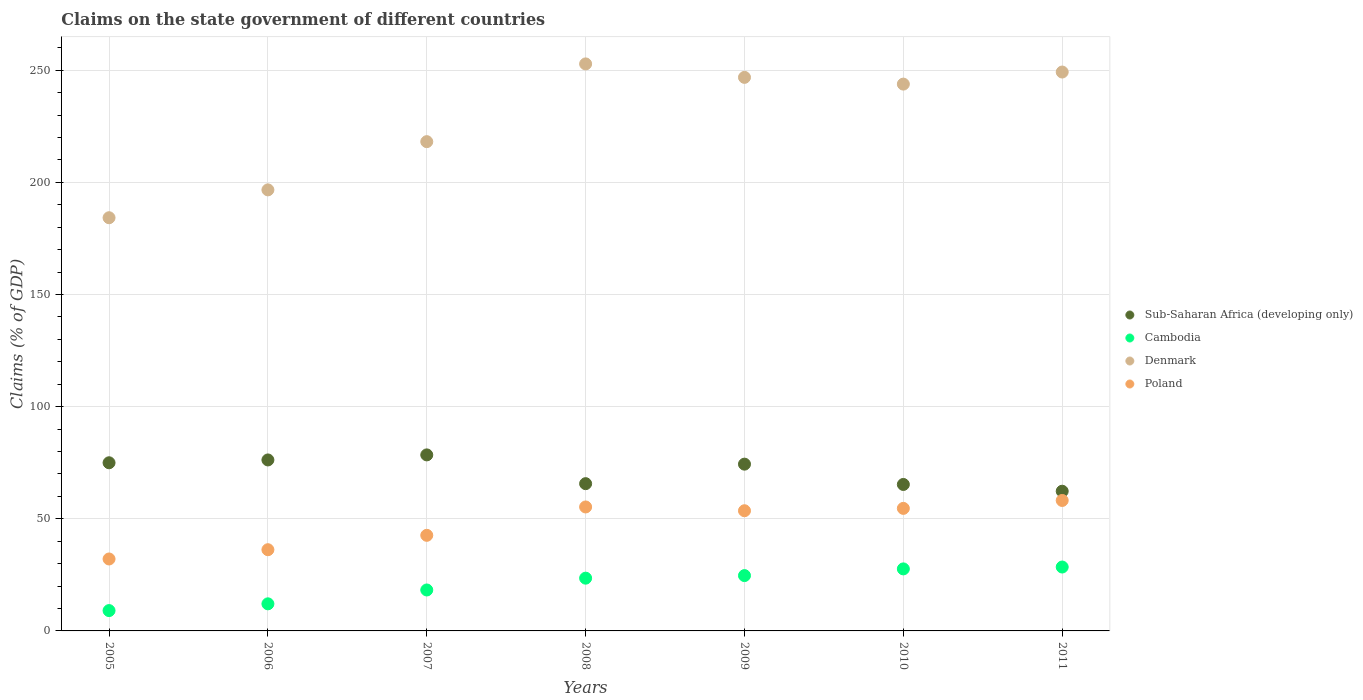Is the number of dotlines equal to the number of legend labels?
Offer a very short reply. Yes. What is the percentage of GDP claimed on the state government in Poland in 2011?
Ensure brevity in your answer.  58.16. Across all years, what is the maximum percentage of GDP claimed on the state government in Cambodia?
Keep it short and to the point. 28.49. Across all years, what is the minimum percentage of GDP claimed on the state government in Poland?
Your response must be concise. 32.08. What is the total percentage of GDP claimed on the state government in Poland in the graph?
Give a very brief answer. 332.55. What is the difference between the percentage of GDP claimed on the state government in Poland in 2005 and that in 2011?
Provide a succinct answer. -26.09. What is the difference between the percentage of GDP claimed on the state government in Cambodia in 2011 and the percentage of GDP claimed on the state government in Denmark in 2008?
Make the answer very short. -224.31. What is the average percentage of GDP claimed on the state government in Cambodia per year?
Provide a short and direct response. 20.53. In the year 2008, what is the difference between the percentage of GDP claimed on the state government in Cambodia and percentage of GDP claimed on the state government in Sub-Saharan Africa (developing only)?
Your answer should be very brief. -42.13. What is the ratio of the percentage of GDP claimed on the state government in Sub-Saharan Africa (developing only) in 2005 to that in 2007?
Offer a very short reply. 0.96. Is the difference between the percentage of GDP claimed on the state government in Cambodia in 2005 and 2008 greater than the difference between the percentage of GDP claimed on the state government in Sub-Saharan Africa (developing only) in 2005 and 2008?
Your response must be concise. No. What is the difference between the highest and the second highest percentage of GDP claimed on the state government in Sub-Saharan Africa (developing only)?
Your answer should be compact. 2.25. What is the difference between the highest and the lowest percentage of GDP claimed on the state government in Sub-Saharan Africa (developing only)?
Offer a very short reply. 16.2. Is it the case that in every year, the sum of the percentage of GDP claimed on the state government in Sub-Saharan Africa (developing only) and percentage of GDP claimed on the state government in Poland  is greater than the percentage of GDP claimed on the state government in Cambodia?
Offer a terse response. Yes. How many dotlines are there?
Your response must be concise. 4. What is the difference between two consecutive major ticks on the Y-axis?
Provide a short and direct response. 50. Does the graph contain any zero values?
Give a very brief answer. No. How many legend labels are there?
Your answer should be very brief. 4. How are the legend labels stacked?
Keep it short and to the point. Vertical. What is the title of the graph?
Your answer should be very brief. Claims on the state government of different countries. Does "Paraguay" appear as one of the legend labels in the graph?
Keep it short and to the point. No. What is the label or title of the Y-axis?
Ensure brevity in your answer.  Claims (% of GDP). What is the Claims (% of GDP) of Sub-Saharan Africa (developing only) in 2005?
Keep it short and to the point. 74.97. What is the Claims (% of GDP) in Cambodia in 2005?
Keep it short and to the point. 9.06. What is the Claims (% of GDP) of Denmark in 2005?
Ensure brevity in your answer.  184.22. What is the Claims (% of GDP) of Poland in 2005?
Your answer should be very brief. 32.08. What is the Claims (% of GDP) in Sub-Saharan Africa (developing only) in 2006?
Give a very brief answer. 76.23. What is the Claims (% of GDP) in Cambodia in 2006?
Provide a succinct answer. 12.08. What is the Claims (% of GDP) of Denmark in 2006?
Provide a short and direct response. 196.64. What is the Claims (% of GDP) of Poland in 2006?
Offer a terse response. 36.21. What is the Claims (% of GDP) in Sub-Saharan Africa (developing only) in 2007?
Your answer should be very brief. 78.48. What is the Claims (% of GDP) in Cambodia in 2007?
Offer a very short reply. 18.25. What is the Claims (% of GDP) of Denmark in 2007?
Provide a succinct answer. 218.14. What is the Claims (% of GDP) of Poland in 2007?
Provide a succinct answer. 42.62. What is the Claims (% of GDP) in Sub-Saharan Africa (developing only) in 2008?
Ensure brevity in your answer.  65.65. What is the Claims (% of GDP) in Cambodia in 2008?
Give a very brief answer. 23.52. What is the Claims (% of GDP) in Denmark in 2008?
Offer a very short reply. 252.8. What is the Claims (% of GDP) of Poland in 2008?
Offer a very short reply. 55.27. What is the Claims (% of GDP) of Sub-Saharan Africa (developing only) in 2009?
Provide a short and direct response. 74.35. What is the Claims (% of GDP) in Cambodia in 2009?
Provide a short and direct response. 24.67. What is the Claims (% of GDP) of Denmark in 2009?
Provide a succinct answer. 246.8. What is the Claims (% of GDP) of Poland in 2009?
Give a very brief answer. 53.58. What is the Claims (% of GDP) in Sub-Saharan Africa (developing only) in 2010?
Ensure brevity in your answer.  65.3. What is the Claims (% of GDP) in Cambodia in 2010?
Your answer should be compact. 27.65. What is the Claims (% of GDP) of Denmark in 2010?
Your response must be concise. 243.79. What is the Claims (% of GDP) in Poland in 2010?
Ensure brevity in your answer.  54.64. What is the Claims (% of GDP) in Sub-Saharan Africa (developing only) in 2011?
Ensure brevity in your answer.  62.28. What is the Claims (% of GDP) in Cambodia in 2011?
Give a very brief answer. 28.49. What is the Claims (% of GDP) of Denmark in 2011?
Make the answer very short. 249.18. What is the Claims (% of GDP) of Poland in 2011?
Offer a terse response. 58.16. Across all years, what is the maximum Claims (% of GDP) in Sub-Saharan Africa (developing only)?
Provide a succinct answer. 78.48. Across all years, what is the maximum Claims (% of GDP) of Cambodia?
Your response must be concise. 28.49. Across all years, what is the maximum Claims (% of GDP) of Denmark?
Offer a terse response. 252.8. Across all years, what is the maximum Claims (% of GDP) in Poland?
Offer a terse response. 58.16. Across all years, what is the minimum Claims (% of GDP) of Sub-Saharan Africa (developing only)?
Your answer should be very brief. 62.28. Across all years, what is the minimum Claims (% of GDP) in Cambodia?
Your response must be concise. 9.06. Across all years, what is the minimum Claims (% of GDP) of Denmark?
Provide a succinct answer. 184.22. Across all years, what is the minimum Claims (% of GDP) in Poland?
Provide a succinct answer. 32.08. What is the total Claims (% of GDP) in Sub-Saharan Africa (developing only) in the graph?
Your answer should be very brief. 497.27. What is the total Claims (% of GDP) of Cambodia in the graph?
Give a very brief answer. 143.72. What is the total Claims (% of GDP) of Denmark in the graph?
Your answer should be very brief. 1591.57. What is the total Claims (% of GDP) in Poland in the graph?
Make the answer very short. 332.55. What is the difference between the Claims (% of GDP) of Sub-Saharan Africa (developing only) in 2005 and that in 2006?
Your answer should be compact. -1.26. What is the difference between the Claims (% of GDP) of Cambodia in 2005 and that in 2006?
Provide a succinct answer. -3.01. What is the difference between the Claims (% of GDP) of Denmark in 2005 and that in 2006?
Offer a terse response. -12.42. What is the difference between the Claims (% of GDP) of Poland in 2005 and that in 2006?
Your response must be concise. -4.13. What is the difference between the Claims (% of GDP) in Sub-Saharan Africa (developing only) in 2005 and that in 2007?
Offer a very short reply. -3.51. What is the difference between the Claims (% of GDP) in Cambodia in 2005 and that in 2007?
Give a very brief answer. -9.19. What is the difference between the Claims (% of GDP) in Denmark in 2005 and that in 2007?
Offer a very short reply. -33.92. What is the difference between the Claims (% of GDP) in Poland in 2005 and that in 2007?
Make the answer very short. -10.54. What is the difference between the Claims (% of GDP) in Sub-Saharan Africa (developing only) in 2005 and that in 2008?
Provide a short and direct response. 9.32. What is the difference between the Claims (% of GDP) in Cambodia in 2005 and that in 2008?
Give a very brief answer. -14.46. What is the difference between the Claims (% of GDP) of Denmark in 2005 and that in 2008?
Ensure brevity in your answer.  -68.58. What is the difference between the Claims (% of GDP) in Poland in 2005 and that in 2008?
Your answer should be compact. -23.19. What is the difference between the Claims (% of GDP) in Sub-Saharan Africa (developing only) in 2005 and that in 2009?
Make the answer very short. 0.62. What is the difference between the Claims (% of GDP) of Cambodia in 2005 and that in 2009?
Your answer should be compact. -15.6. What is the difference between the Claims (% of GDP) in Denmark in 2005 and that in 2009?
Ensure brevity in your answer.  -62.58. What is the difference between the Claims (% of GDP) of Poland in 2005 and that in 2009?
Give a very brief answer. -21.51. What is the difference between the Claims (% of GDP) of Sub-Saharan Africa (developing only) in 2005 and that in 2010?
Your answer should be compact. 9.67. What is the difference between the Claims (% of GDP) in Cambodia in 2005 and that in 2010?
Your response must be concise. -18.59. What is the difference between the Claims (% of GDP) of Denmark in 2005 and that in 2010?
Your answer should be compact. -59.58. What is the difference between the Claims (% of GDP) in Poland in 2005 and that in 2010?
Make the answer very short. -22.56. What is the difference between the Claims (% of GDP) in Sub-Saharan Africa (developing only) in 2005 and that in 2011?
Make the answer very short. 12.69. What is the difference between the Claims (% of GDP) of Cambodia in 2005 and that in 2011?
Give a very brief answer. -19.42. What is the difference between the Claims (% of GDP) of Denmark in 2005 and that in 2011?
Your response must be concise. -64.96. What is the difference between the Claims (% of GDP) of Poland in 2005 and that in 2011?
Your response must be concise. -26.09. What is the difference between the Claims (% of GDP) in Sub-Saharan Africa (developing only) in 2006 and that in 2007?
Your answer should be very brief. -2.25. What is the difference between the Claims (% of GDP) of Cambodia in 2006 and that in 2007?
Your answer should be compact. -6.18. What is the difference between the Claims (% of GDP) in Denmark in 2006 and that in 2007?
Keep it short and to the point. -21.5. What is the difference between the Claims (% of GDP) in Poland in 2006 and that in 2007?
Keep it short and to the point. -6.41. What is the difference between the Claims (% of GDP) in Sub-Saharan Africa (developing only) in 2006 and that in 2008?
Keep it short and to the point. 10.58. What is the difference between the Claims (% of GDP) in Cambodia in 2006 and that in 2008?
Give a very brief answer. -11.45. What is the difference between the Claims (% of GDP) in Denmark in 2006 and that in 2008?
Make the answer very short. -56.16. What is the difference between the Claims (% of GDP) of Poland in 2006 and that in 2008?
Ensure brevity in your answer.  -19.06. What is the difference between the Claims (% of GDP) of Sub-Saharan Africa (developing only) in 2006 and that in 2009?
Offer a very short reply. 1.88. What is the difference between the Claims (% of GDP) in Cambodia in 2006 and that in 2009?
Keep it short and to the point. -12.59. What is the difference between the Claims (% of GDP) of Denmark in 2006 and that in 2009?
Keep it short and to the point. -50.16. What is the difference between the Claims (% of GDP) in Poland in 2006 and that in 2009?
Give a very brief answer. -17.37. What is the difference between the Claims (% of GDP) in Sub-Saharan Africa (developing only) in 2006 and that in 2010?
Ensure brevity in your answer.  10.93. What is the difference between the Claims (% of GDP) of Cambodia in 2006 and that in 2010?
Offer a terse response. -15.58. What is the difference between the Claims (% of GDP) of Denmark in 2006 and that in 2010?
Give a very brief answer. -47.15. What is the difference between the Claims (% of GDP) in Poland in 2006 and that in 2010?
Make the answer very short. -18.43. What is the difference between the Claims (% of GDP) in Sub-Saharan Africa (developing only) in 2006 and that in 2011?
Provide a short and direct response. 13.95. What is the difference between the Claims (% of GDP) of Cambodia in 2006 and that in 2011?
Offer a very short reply. -16.41. What is the difference between the Claims (% of GDP) in Denmark in 2006 and that in 2011?
Your response must be concise. -52.54. What is the difference between the Claims (% of GDP) of Poland in 2006 and that in 2011?
Your response must be concise. -21.96. What is the difference between the Claims (% of GDP) of Sub-Saharan Africa (developing only) in 2007 and that in 2008?
Your answer should be very brief. 12.83. What is the difference between the Claims (% of GDP) of Cambodia in 2007 and that in 2008?
Provide a short and direct response. -5.27. What is the difference between the Claims (% of GDP) of Denmark in 2007 and that in 2008?
Your answer should be compact. -34.66. What is the difference between the Claims (% of GDP) of Poland in 2007 and that in 2008?
Your answer should be very brief. -12.65. What is the difference between the Claims (% of GDP) of Sub-Saharan Africa (developing only) in 2007 and that in 2009?
Give a very brief answer. 4.13. What is the difference between the Claims (% of GDP) of Cambodia in 2007 and that in 2009?
Offer a very short reply. -6.42. What is the difference between the Claims (% of GDP) of Denmark in 2007 and that in 2009?
Provide a succinct answer. -28.66. What is the difference between the Claims (% of GDP) in Poland in 2007 and that in 2009?
Your answer should be very brief. -10.96. What is the difference between the Claims (% of GDP) of Sub-Saharan Africa (developing only) in 2007 and that in 2010?
Your answer should be compact. 13.18. What is the difference between the Claims (% of GDP) in Cambodia in 2007 and that in 2010?
Make the answer very short. -9.4. What is the difference between the Claims (% of GDP) in Denmark in 2007 and that in 2010?
Provide a succinct answer. -25.66. What is the difference between the Claims (% of GDP) of Poland in 2007 and that in 2010?
Ensure brevity in your answer.  -12.01. What is the difference between the Claims (% of GDP) of Sub-Saharan Africa (developing only) in 2007 and that in 2011?
Offer a very short reply. 16.2. What is the difference between the Claims (% of GDP) in Cambodia in 2007 and that in 2011?
Your answer should be very brief. -10.23. What is the difference between the Claims (% of GDP) of Denmark in 2007 and that in 2011?
Provide a short and direct response. -31.04. What is the difference between the Claims (% of GDP) in Poland in 2007 and that in 2011?
Provide a succinct answer. -15.54. What is the difference between the Claims (% of GDP) in Sub-Saharan Africa (developing only) in 2008 and that in 2009?
Your answer should be very brief. -8.7. What is the difference between the Claims (% of GDP) of Cambodia in 2008 and that in 2009?
Keep it short and to the point. -1.15. What is the difference between the Claims (% of GDP) of Denmark in 2008 and that in 2009?
Offer a very short reply. 6. What is the difference between the Claims (% of GDP) of Poland in 2008 and that in 2009?
Your answer should be compact. 1.68. What is the difference between the Claims (% of GDP) of Sub-Saharan Africa (developing only) in 2008 and that in 2010?
Provide a short and direct response. 0.35. What is the difference between the Claims (% of GDP) of Cambodia in 2008 and that in 2010?
Keep it short and to the point. -4.13. What is the difference between the Claims (% of GDP) in Denmark in 2008 and that in 2010?
Keep it short and to the point. 9.01. What is the difference between the Claims (% of GDP) in Poland in 2008 and that in 2010?
Provide a succinct answer. 0.63. What is the difference between the Claims (% of GDP) of Sub-Saharan Africa (developing only) in 2008 and that in 2011?
Your answer should be compact. 3.37. What is the difference between the Claims (% of GDP) in Cambodia in 2008 and that in 2011?
Your response must be concise. -4.97. What is the difference between the Claims (% of GDP) in Denmark in 2008 and that in 2011?
Offer a very short reply. 3.62. What is the difference between the Claims (% of GDP) in Poland in 2008 and that in 2011?
Your answer should be compact. -2.9. What is the difference between the Claims (% of GDP) of Sub-Saharan Africa (developing only) in 2009 and that in 2010?
Provide a short and direct response. 9.06. What is the difference between the Claims (% of GDP) in Cambodia in 2009 and that in 2010?
Your answer should be compact. -2.98. What is the difference between the Claims (% of GDP) in Denmark in 2009 and that in 2010?
Provide a succinct answer. 3. What is the difference between the Claims (% of GDP) in Poland in 2009 and that in 2010?
Offer a very short reply. -1.05. What is the difference between the Claims (% of GDP) in Sub-Saharan Africa (developing only) in 2009 and that in 2011?
Give a very brief answer. 12.07. What is the difference between the Claims (% of GDP) in Cambodia in 2009 and that in 2011?
Offer a very short reply. -3.82. What is the difference between the Claims (% of GDP) in Denmark in 2009 and that in 2011?
Provide a short and direct response. -2.38. What is the difference between the Claims (% of GDP) in Poland in 2009 and that in 2011?
Ensure brevity in your answer.  -4.58. What is the difference between the Claims (% of GDP) in Sub-Saharan Africa (developing only) in 2010 and that in 2011?
Offer a very short reply. 3.01. What is the difference between the Claims (% of GDP) of Cambodia in 2010 and that in 2011?
Offer a very short reply. -0.83. What is the difference between the Claims (% of GDP) of Denmark in 2010 and that in 2011?
Your answer should be compact. -5.38. What is the difference between the Claims (% of GDP) of Poland in 2010 and that in 2011?
Ensure brevity in your answer.  -3.53. What is the difference between the Claims (% of GDP) of Sub-Saharan Africa (developing only) in 2005 and the Claims (% of GDP) of Cambodia in 2006?
Offer a very short reply. 62.89. What is the difference between the Claims (% of GDP) of Sub-Saharan Africa (developing only) in 2005 and the Claims (% of GDP) of Denmark in 2006?
Offer a terse response. -121.67. What is the difference between the Claims (% of GDP) in Sub-Saharan Africa (developing only) in 2005 and the Claims (% of GDP) in Poland in 2006?
Your answer should be compact. 38.76. What is the difference between the Claims (% of GDP) of Cambodia in 2005 and the Claims (% of GDP) of Denmark in 2006?
Your response must be concise. -187.58. What is the difference between the Claims (% of GDP) in Cambodia in 2005 and the Claims (% of GDP) in Poland in 2006?
Your answer should be compact. -27.15. What is the difference between the Claims (% of GDP) of Denmark in 2005 and the Claims (% of GDP) of Poland in 2006?
Keep it short and to the point. 148.01. What is the difference between the Claims (% of GDP) of Sub-Saharan Africa (developing only) in 2005 and the Claims (% of GDP) of Cambodia in 2007?
Offer a very short reply. 56.72. What is the difference between the Claims (% of GDP) in Sub-Saharan Africa (developing only) in 2005 and the Claims (% of GDP) in Denmark in 2007?
Your response must be concise. -143.17. What is the difference between the Claims (% of GDP) of Sub-Saharan Africa (developing only) in 2005 and the Claims (% of GDP) of Poland in 2007?
Keep it short and to the point. 32.35. What is the difference between the Claims (% of GDP) of Cambodia in 2005 and the Claims (% of GDP) of Denmark in 2007?
Your answer should be compact. -209.07. What is the difference between the Claims (% of GDP) in Cambodia in 2005 and the Claims (% of GDP) in Poland in 2007?
Ensure brevity in your answer.  -33.56. What is the difference between the Claims (% of GDP) in Denmark in 2005 and the Claims (% of GDP) in Poland in 2007?
Ensure brevity in your answer.  141.6. What is the difference between the Claims (% of GDP) of Sub-Saharan Africa (developing only) in 2005 and the Claims (% of GDP) of Cambodia in 2008?
Provide a short and direct response. 51.45. What is the difference between the Claims (% of GDP) of Sub-Saharan Africa (developing only) in 2005 and the Claims (% of GDP) of Denmark in 2008?
Provide a short and direct response. -177.83. What is the difference between the Claims (% of GDP) of Sub-Saharan Africa (developing only) in 2005 and the Claims (% of GDP) of Poland in 2008?
Give a very brief answer. 19.7. What is the difference between the Claims (% of GDP) in Cambodia in 2005 and the Claims (% of GDP) in Denmark in 2008?
Your response must be concise. -243.74. What is the difference between the Claims (% of GDP) of Cambodia in 2005 and the Claims (% of GDP) of Poland in 2008?
Make the answer very short. -46.2. What is the difference between the Claims (% of GDP) of Denmark in 2005 and the Claims (% of GDP) of Poland in 2008?
Your answer should be compact. 128.95. What is the difference between the Claims (% of GDP) of Sub-Saharan Africa (developing only) in 2005 and the Claims (% of GDP) of Cambodia in 2009?
Your answer should be compact. 50.3. What is the difference between the Claims (% of GDP) in Sub-Saharan Africa (developing only) in 2005 and the Claims (% of GDP) in Denmark in 2009?
Your answer should be compact. -171.83. What is the difference between the Claims (% of GDP) in Sub-Saharan Africa (developing only) in 2005 and the Claims (% of GDP) in Poland in 2009?
Offer a very short reply. 21.39. What is the difference between the Claims (% of GDP) of Cambodia in 2005 and the Claims (% of GDP) of Denmark in 2009?
Provide a succinct answer. -237.74. What is the difference between the Claims (% of GDP) in Cambodia in 2005 and the Claims (% of GDP) in Poland in 2009?
Give a very brief answer. -44.52. What is the difference between the Claims (% of GDP) of Denmark in 2005 and the Claims (% of GDP) of Poland in 2009?
Provide a short and direct response. 130.64. What is the difference between the Claims (% of GDP) in Sub-Saharan Africa (developing only) in 2005 and the Claims (% of GDP) in Cambodia in 2010?
Make the answer very short. 47.32. What is the difference between the Claims (% of GDP) in Sub-Saharan Africa (developing only) in 2005 and the Claims (% of GDP) in Denmark in 2010?
Give a very brief answer. -168.82. What is the difference between the Claims (% of GDP) in Sub-Saharan Africa (developing only) in 2005 and the Claims (% of GDP) in Poland in 2010?
Provide a short and direct response. 20.34. What is the difference between the Claims (% of GDP) in Cambodia in 2005 and the Claims (% of GDP) in Denmark in 2010?
Give a very brief answer. -234.73. What is the difference between the Claims (% of GDP) in Cambodia in 2005 and the Claims (% of GDP) in Poland in 2010?
Ensure brevity in your answer.  -45.57. What is the difference between the Claims (% of GDP) of Denmark in 2005 and the Claims (% of GDP) of Poland in 2010?
Provide a short and direct response. 129.58. What is the difference between the Claims (% of GDP) of Sub-Saharan Africa (developing only) in 2005 and the Claims (% of GDP) of Cambodia in 2011?
Ensure brevity in your answer.  46.48. What is the difference between the Claims (% of GDP) of Sub-Saharan Africa (developing only) in 2005 and the Claims (% of GDP) of Denmark in 2011?
Offer a terse response. -174.21. What is the difference between the Claims (% of GDP) in Sub-Saharan Africa (developing only) in 2005 and the Claims (% of GDP) in Poland in 2011?
Your answer should be compact. 16.81. What is the difference between the Claims (% of GDP) in Cambodia in 2005 and the Claims (% of GDP) in Denmark in 2011?
Give a very brief answer. -240.11. What is the difference between the Claims (% of GDP) of Cambodia in 2005 and the Claims (% of GDP) of Poland in 2011?
Your answer should be very brief. -49.1. What is the difference between the Claims (% of GDP) in Denmark in 2005 and the Claims (% of GDP) in Poland in 2011?
Offer a very short reply. 126.05. What is the difference between the Claims (% of GDP) of Sub-Saharan Africa (developing only) in 2006 and the Claims (% of GDP) of Cambodia in 2007?
Provide a short and direct response. 57.98. What is the difference between the Claims (% of GDP) in Sub-Saharan Africa (developing only) in 2006 and the Claims (% of GDP) in Denmark in 2007?
Provide a short and direct response. -141.91. What is the difference between the Claims (% of GDP) of Sub-Saharan Africa (developing only) in 2006 and the Claims (% of GDP) of Poland in 2007?
Ensure brevity in your answer.  33.61. What is the difference between the Claims (% of GDP) in Cambodia in 2006 and the Claims (% of GDP) in Denmark in 2007?
Give a very brief answer. -206.06. What is the difference between the Claims (% of GDP) in Cambodia in 2006 and the Claims (% of GDP) in Poland in 2007?
Offer a terse response. -30.54. What is the difference between the Claims (% of GDP) of Denmark in 2006 and the Claims (% of GDP) of Poland in 2007?
Ensure brevity in your answer.  154.02. What is the difference between the Claims (% of GDP) of Sub-Saharan Africa (developing only) in 2006 and the Claims (% of GDP) of Cambodia in 2008?
Make the answer very short. 52.71. What is the difference between the Claims (% of GDP) of Sub-Saharan Africa (developing only) in 2006 and the Claims (% of GDP) of Denmark in 2008?
Your response must be concise. -176.57. What is the difference between the Claims (% of GDP) of Sub-Saharan Africa (developing only) in 2006 and the Claims (% of GDP) of Poland in 2008?
Your answer should be very brief. 20.97. What is the difference between the Claims (% of GDP) in Cambodia in 2006 and the Claims (% of GDP) in Denmark in 2008?
Offer a terse response. -240.72. What is the difference between the Claims (% of GDP) in Cambodia in 2006 and the Claims (% of GDP) in Poland in 2008?
Provide a succinct answer. -43.19. What is the difference between the Claims (% of GDP) of Denmark in 2006 and the Claims (% of GDP) of Poland in 2008?
Offer a terse response. 141.38. What is the difference between the Claims (% of GDP) in Sub-Saharan Africa (developing only) in 2006 and the Claims (% of GDP) in Cambodia in 2009?
Give a very brief answer. 51.56. What is the difference between the Claims (% of GDP) of Sub-Saharan Africa (developing only) in 2006 and the Claims (% of GDP) of Denmark in 2009?
Make the answer very short. -170.57. What is the difference between the Claims (% of GDP) of Sub-Saharan Africa (developing only) in 2006 and the Claims (% of GDP) of Poland in 2009?
Your answer should be very brief. 22.65. What is the difference between the Claims (% of GDP) of Cambodia in 2006 and the Claims (% of GDP) of Denmark in 2009?
Your response must be concise. -234.72. What is the difference between the Claims (% of GDP) in Cambodia in 2006 and the Claims (% of GDP) in Poland in 2009?
Give a very brief answer. -41.5. What is the difference between the Claims (% of GDP) in Denmark in 2006 and the Claims (% of GDP) in Poland in 2009?
Your answer should be very brief. 143.06. What is the difference between the Claims (% of GDP) in Sub-Saharan Africa (developing only) in 2006 and the Claims (% of GDP) in Cambodia in 2010?
Your answer should be very brief. 48.58. What is the difference between the Claims (% of GDP) of Sub-Saharan Africa (developing only) in 2006 and the Claims (% of GDP) of Denmark in 2010?
Your response must be concise. -167.56. What is the difference between the Claims (% of GDP) in Sub-Saharan Africa (developing only) in 2006 and the Claims (% of GDP) in Poland in 2010?
Provide a short and direct response. 21.6. What is the difference between the Claims (% of GDP) of Cambodia in 2006 and the Claims (% of GDP) of Denmark in 2010?
Ensure brevity in your answer.  -231.72. What is the difference between the Claims (% of GDP) in Cambodia in 2006 and the Claims (% of GDP) in Poland in 2010?
Offer a very short reply. -42.56. What is the difference between the Claims (% of GDP) of Denmark in 2006 and the Claims (% of GDP) of Poland in 2010?
Offer a terse response. 142.01. What is the difference between the Claims (% of GDP) of Sub-Saharan Africa (developing only) in 2006 and the Claims (% of GDP) of Cambodia in 2011?
Make the answer very short. 47.74. What is the difference between the Claims (% of GDP) in Sub-Saharan Africa (developing only) in 2006 and the Claims (% of GDP) in Denmark in 2011?
Give a very brief answer. -172.95. What is the difference between the Claims (% of GDP) in Sub-Saharan Africa (developing only) in 2006 and the Claims (% of GDP) in Poland in 2011?
Offer a very short reply. 18.07. What is the difference between the Claims (% of GDP) in Cambodia in 2006 and the Claims (% of GDP) in Denmark in 2011?
Give a very brief answer. -237.1. What is the difference between the Claims (% of GDP) in Cambodia in 2006 and the Claims (% of GDP) in Poland in 2011?
Make the answer very short. -46.09. What is the difference between the Claims (% of GDP) of Denmark in 2006 and the Claims (% of GDP) of Poland in 2011?
Offer a terse response. 138.48. What is the difference between the Claims (% of GDP) in Sub-Saharan Africa (developing only) in 2007 and the Claims (% of GDP) in Cambodia in 2008?
Offer a very short reply. 54.96. What is the difference between the Claims (% of GDP) in Sub-Saharan Africa (developing only) in 2007 and the Claims (% of GDP) in Denmark in 2008?
Ensure brevity in your answer.  -174.32. What is the difference between the Claims (% of GDP) of Sub-Saharan Africa (developing only) in 2007 and the Claims (% of GDP) of Poland in 2008?
Offer a terse response. 23.22. What is the difference between the Claims (% of GDP) of Cambodia in 2007 and the Claims (% of GDP) of Denmark in 2008?
Keep it short and to the point. -234.55. What is the difference between the Claims (% of GDP) in Cambodia in 2007 and the Claims (% of GDP) in Poland in 2008?
Give a very brief answer. -37.01. What is the difference between the Claims (% of GDP) in Denmark in 2007 and the Claims (% of GDP) in Poland in 2008?
Provide a short and direct response. 162.87. What is the difference between the Claims (% of GDP) in Sub-Saharan Africa (developing only) in 2007 and the Claims (% of GDP) in Cambodia in 2009?
Your answer should be compact. 53.81. What is the difference between the Claims (% of GDP) in Sub-Saharan Africa (developing only) in 2007 and the Claims (% of GDP) in Denmark in 2009?
Your answer should be very brief. -168.32. What is the difference between the Claims (% of GDP) in Sub-Saharan Africa (developing only) in 2007 and the Claims (% of GDP) in Poland in 2009?
Provide a short and direct response. 24.9. What is the difference between the Claims (% of GDP) of Cambodia in 2007 and the Claims (% of GDP) of Denmark in 2009?
Provide a succinct answer. -228.55. What is the difference between the Claims (% of GDP) of Cambodia in 2007 and the Claims (% of GDP) of Poland in 2009?
Your answer should be very brief. -35.33. What is the difference between the Claims (% of GDP) in Denmark in 2007 and the Claims (% of GDP) in Poland in 2009?
Make the answer very short. 164.56. What is the difference between the Claims (% of GDP) of Sub-Saharan Africa (developing only) in 2007 and the Claims (% of GDP) of Cambodia in 2010?
Make the answer very short. 50.83. What is the difference between the Claims (% of GDP) in Sub-Saharan Africa (developing only) in 2007 and the Claims (% of GDP) in Denmark in 2010?
Ensure brevity in your answer.  -165.31. What is the difference between the Claims (% of GDP) of Sub-Saharan Africa (developing only) in 2007 and the Claims (% of GDP) of Poland in 2010?
Make the answer very short. 23.85. What is the difference between the Claims (% of GDP) in Cambodia in 2007 and the Claims (% of GDP) in Denmark in 2010?
Provide a succinct answer. -225.54. What is the difference between the Claims (% of GDP) in Cambodia in 2007 and the Claims (% of GDP) in Poland in 2010?
Ensure brevity in your answer.  -36.38. What is the difference between the Claims (% of GDP) in Denmark in 2007 and the Claims (% of GDP) in Poland in 2010?
Your answer should be very brief. 163.5. What is the difference between the Claims (% of GDP) of Sub-Saharan Africa (developing only) in 2007 and the Claims (% of GDP) of Cambodia in 2011?
Give a very brief answer. 49.99. What is the difference between the Claims (% of GDP) in Sub-Saharan Africa (developing only) in 2007 and the Claims (% of GDP) in Denmark in 2011?
Provide a succinct answer. -170.7. What is the difference between the Claims (% of GDP) in Sub-Saharan Africa (developing only) in 2007 and the Claims (% of GDP) in Poland in 2011?
Offer a terse response. 20.32. What is the difference between the Claims (% of GDP) of Cambodia in 2007 and the Claims (% of GDP) of Denmark in 2011?
Make the answer very short. -230.93. What is the difference between the Claims (% of GDP) in Cambodia in 2007 and the Claims (% of GDP) in Poland in 2011?
Your response must be concise. -39.91. What is the difference between the Claims (% of GDP) of Denmark in 2007 and the Claims (% of GDP) of Poland in 2011?
Offer a very short reply. 159.97. What is the difference between the Claims (% of GDP) of Sub-Saharan Africa (developing only) in 2008 and the Claims (% of GDP) of Cambodia in 2009?
Offer a very short reply. 40.98. What is the difference between the Claims (% of GDP) of Sub-Saharan Africa (developing only) in 2008 and the Claims (% of GDP) of Denmark in 2009?
Keep it short and to the point. -181.15. What is the difference between the Claims (% of GDP) of Sub-Saharan Africa (developing only) in 2008 and the Claims (% of GDP) of Poland in 2009?
Keep it short and to the point. 12.07. What is the difference between the Claims (% of GDP) of Cambodia in 2008 and the Claims (% of GDP) of Denmark in 2009?
Keep it short and to the point. -223.28. What is the difference between the Claims (% of GDP) of Cambodia in 2008 and the Claims (% of GDP) of Poland in 2009?
Provide a succinct answer. -30.06. What is the difference between the Claims (% of GDP) of Denmark in 2008 and the Claims (% of GDP) of Poland in 2009?
Give a very brief answer. 199.22. What is the difference between the Claims (% of GDP) of Sub-Saharan Africa (developing only) in 2008 and the Claims (% of GDP) of Cambodia in 2010?
Your answer should be compact. 38. What is the difference between the Claims (% of GDP) in Sub-Saharan Africa (developing only) in 2008 and the Claims (% of GDP) in Denmark in 2010?
Offer a very short reply. -178.14. What is the difference between the Claims (% of GDP) in Sub-Saharan Africa (developing only) in 2008 and the Claims (% of GDP) in Poland in 2010?
Give a very brief answer. 11.02. What is the difference between the Claims (% of GDP) in Cambodia in 2008 and the Claims (% of GDP) in Denmark in 2010?
Keep it short and to the point. -220.27. What is the difference between the Claims (% of GDP) of Cambodia in 2008 and the Claims (% of GDP) of Poland in 2010?
Provide a succinct answer. -31.11. What is the difference between the Claims (% of GDP) of Denmark in 2008 and the Claims (% of GDP) of Poland in 2010?
Your answer should be compact. 198.17. What is the difference between the Claims (% of GDP) in Sub-Saharan Africa (developing only) in 2008 and the Claims (% of GDP) in Cambodia in 2011?
Keep it short and to the point. 37.16. What is the difference between the Claims (% of GDP) of Sub-Saharan Africa (developing only) in 2008 and the Claims (% of GDP) of Denmark in 2011?
Provide a short and direct response. -183.53. What is the difference between the Claims (% of GDP) in Sub-Saharan Africa (developing only) in 2008 and the Claims (% of GDP) in Poland in 2011?
Keep it short and to the point. 7.49. What is the difference between the Claims (% of GDP) in Cambodia in 2008 and the Claims (% of GDP) in Denmark in 2011?
Offer a very short reply. -225.66. What is the difference between the Claims (% of GDP) of Cambodia in 2008 and the Claims (% of GDP) of Poland in 2011?
Make the answer very short. -34.64. What is the difference between the Claims (% of GDP) in Denmark in 2008 and the Claims (% of GDP) in Poland in 2011?
Offer a terse response. 194.64. What is the difference between the Claims (% of GDP) in Sub-Saharan Africa (developing only) in 2009 and the Claims (% of GDP) in Cambodia in 2010?
Your answer should be very brief. 46.7. What is the difference between the Claims (% of GDP) of Sub-Saharan Africa (developing only) in 2009 and the Claims (% of GDP) of Denmark in 2010?
Offer a very short reply. -169.44. What is the difference between the Claims (% of GDP) of Sub-Saharan Africa (developing only) in 2009 and the Claims (% of GDP) of Poland in 2010?
Provide a short and direct response. 19.72. What is the difference between the Claims (% of GDP) of Cambodia in 2009 and the Claims (% of GDP) of Denmark in 2010?
Make the answer very short. -219.13. What is the difference between the Claims (% of GDP) of Cambodia in 2009 and the Claims (% of GDP) of Poland in 2010?
Make the answer very short. -29.97. What is the difference between the Claims (% of GDP) of Denmark in 2009 and the Claims (% of GDP) of Poland in 2010?
Offer a very short reply. 192.16. What is the difference between the Claims (% of GDP) in Sub-Saharan Africa (developing only) in 2009 and the Claims (% of GDP) in Cambodia in 2011?
Ensure brevity in your answer.  45.87. What is the difference between the Claims (% of GDP) of Sub-Saharan Africa (developing only) in 2009 and the Claims (% of GDP) of Denmark in 2011?
Ensure brevity in your answer.  -174.82. What is the difference between the Claims (% of GDP) in Sub-Saharan Africa (developing only) in 2009 and the Claims (% of GDP) in Poland in 2011?
Your answer should be compact. 16.19. What is the difference between the Claims (% of GDP) in Cambodia in 2009 and the Claims (% of GDP) in Denmark in 2011?
Offer a very short reply. -224.51. What is the difference between the Claims (% of GDP) of Cambodia in 2009 and the Claims (% of GDP) of Poland in 2011?
Provide a succinct answer. -33.5. What is the difference between the Claims (% of GDP) in Denmark in 2009 and the Claims (% of GDP) in Poland in 2011?
Offer a very short reply. 188.63. What is the difference between the Claims (% of GDP) of Sub-Saharan Africa (developing only) in 2010 and the Claims (% of GDP) of Cambodia in 2011?
Offer a very short reply. 36.81. What is the difference between the Claims (% of GDP) of Sub-Saharan Africa (developing only) in 2010 and the Claims (% of GDP) of Denmark in 2011?
Give a very brief answer. -183.88. What is the difference between the Claims (% of GDP) of Sub-Saharan Africa (developing only) in 2010 and the Claims (% of GDP) of Poland in 2011?
Your answer should be very brief. 7.13. What is the difference between the Claims (% of GDP) of Cambodia in 2010 and the Claims (% of GDP) of Denmark in 2011?
Keep it short and to the point. -221.52. What is the difference between the Claims (% of GDP) of Cambodia in 2010 and the Claims (% of GDP) of Poland in 2011?
Keep it short and to the point. -30.51. What is the difference between the Claims (% of GDP) of Denmark in 2010 and the Claims (% of GDP) of Poland in 2011?
Make the answer very short. 185.63. What is the average Claims (% of GDP) in Sub-Saharan Africa (developing only) per year?
Ensure brevity in your answer.  71.04. What is the average Claims (% of GDP) in Cambodia per year?
Make the answer very short. 20.53. What is the average Claims (% of GDP) in Denmark per year?
Ensure brevity in your answer.  227.37. What is the average Claims (% of GDP) in Poland per year?
Offer a terse response. 47.51. In the year 2005, what is the difference between the Claims (% of GDP) of Sub-Saharan Africa (developing only) and Claims (% of GDP) of Cambodia?
Your answer should be compact. 65.91. In the year 2005, what is the difference between the Claims (% of GDP) in Sub-Saharan Africa (developing only) and Claims (% of GDP) in Denmark?
Your answer should be compact. -109.25. In the year 2005, what is the difference between the Claims (% of GDP) in Sub-Saharan Africa (developing only) and Claims (% of GDP) in Poland?
Keep it short and to the point. 42.89. In the year 2005, what is the difference between the Claims (% of GDP) in Cambodia and Claims (% of GDP) in Denmark?
Your answer should be very brief. -175.15. In the year 2005, what is the difference between the Claims (% of GDP) in Cambodia and Claims (% of GDP) in Poland?
Give a very brief answer. -23.01. In the year 2005, what is the difference between the Claims (% of GDP) of Denmark and Claims (% of GDP) of Poland?
Provide a succinct answer. 152.14. In the year 2006, what is the difference between the Claims (% of GDP) of Sub-Saharan Africa (developing only) and Claims (% of GDP) of Cambodia?
Ensure brevity in your answer.  64.16. In the year 2006, what is the difference between the Claims (% of GDP) of Sub-Saharan Africa (developing only) and Claims (% of GDP) of Denmark?
Keep it short and to the point. -120.41. In the year 2006, what is the difference between the Claims (% of GDP) of Sub-Saharan Africa (developing only) and Claims (% of GDP) of Poland?
Offer a very short reply. 40.02. In the year 2006, what is the difference between the Claims (% of GDP) of Cambodia and Claims (% of GDP) of Denmark?
Offer a very short reply. -184.56. In the year 2006, what is the difference between the Claims (% of GDP) of Cambodia and Claims (% of GDP) of Poland?
Make the answer very short. -24.13. In the year 2006, what is the difference between the Claims (% of GDP) of Denmark and Claims (% of GDP) of Poland?
Your response must be concise. 160.43. In the year 2007, what is the difference between the Claims (% of GDP) of Sub-Saharan Africa (developing only) and Claims (% of GDP) of Cambodia?
Your response must be concise. 60.23. In the year 2007, what is the difference between the Claims (% of GDP) in Sub-Saharan Africa (developing only) and Claims (% of GDP) in Denmark?
Make the answer very short. -139.66. In the year 2007, what is the difference between the Claims (% of GDP) of Sub-Saharan Africa (developing only) and Claims (% of GDP) of Poland?
Provide a succinct answer. 35.86. In the year 2007, what is the difference between the Claims (% of GDP) of Cambodia and Claims (% of GDP) of Denmark?
Your response must be concise. -199.88. In the year 2007, what is the difference between the Claims (% of GDP) in Cambodia and Claims (% of GDP) in Poland?
Provide a short and direct response. -24.37. In the year 2007, what is the difference between the Claims (% of GDP) in Denmark and Claims (% of GDP) in Poland?
Make the answer very short. 175.52. In the year 2008, what is the difference between the Claims (% of GDP) of Sub-Saharan Africa (developing only) and Claims (% of GDP) of Cambodia?
Keep it short and to the point. 42.13. In the year 2008, what is the difference between the Claims (% of GDP) in Sub-Saharan Africa (developing only) and Claims (% of GDP) in Denmark?
Ensure brevity in your answer.  -187.15. In the year 2008, what is the difference between the Claims (% of GDP) in Sub-Saharan Africa (developing only) and Claims (% of GDP) in Poland?
Ensure brevity in your answer.  10.39. In the year 2008, what is the difference between the Claims (% of GDP) of Cambodia and Claims (% of GDP) of Denmark?
Your response must be concise. -229.28. In the year 2008, what is the difference between the Claims (% of GDP) of Cambodia and Claims (% of GDP) of Poland?
Offer a very short reply. -31.74. In the year 2008, what is the difference between the Claims (% of GDP) in Denmark and Claims (% of GDP) in Poland?
Keep it short and to the point. 197.53. In the year 2009, what is the difference between the Claims (% of GDP) of Sub-Saharan Africa (developing only) and Claims (% of GDP) of Cambodia?
Give a very brief answer. 49.69. In the year 2009, what is the difference between the Claims (% of GDP) of Sub-Saharan Africa (developing only) and Claims (% of GDP) of Denmark?
Provide a short and direct response. -172.44. In the year 2009, what is the difference between the Claims (% of GDP) of Sub-Saharan Africa (developing only) and Claims (% of GDP) of Poland?
Provide a succinct answer. 20.77. In the year 2009, what is the difference between the Claims (% of GDP) of Cambodia and Claims (% of GDP) of Denmark?
Provide a short and direct response. -222.13. In the year 2009, what is the difference between the Claims (% of GDP) in Cambodia and Claims (% of GDP) in Poland?
Provide a succinct answer. -28.91. In the year 2009, what is the difference between the Claims (% of GDP) in Denmark and Claims (% of GDP) in Poland?
Keep it short and to the point. 193.22. In the year 2010, what is the difference between the Claims (% of GDP) in Sub-Saharan Africa (developing only) and Claims (% of GDP) in Cambodia?
Your answer should be very brief. 37.65. In the year 2010, what is the difference between the Claims (% of GDP) of Sub-Saharan Africa (developing only) and Claims (% of GDP) of Denmark?
Provide a succinct answer. -178.5. In the year 2010, what is the difference between the Claims (% of GDP) in Sub-Saharan Africa (developing only) and Claims (% of GDP) in Poland?
Give a very brief answer. 10.66. In the year 2010, what is the difference between the Claims (% of GDP) of Cambodia and Claims (% of GDP) of Denmark?
Give a very brief answer. -216.14. In the year 2010, what is the difference between the Claims (% of GDP) of Cambodia and Claims (% of GDP) of Poland?
Your answer should be very brief. -26.98. In the year 2010, what is the difference between the Claims (% of GDP) of Denmark and Claims (% of GDP) of Poland?
Your answer should be very brief. 189.16. In the year 2011, what is the difference between the Claims (% of GDP) in Sub-Saharan Africa (developing only) and Claims (% of GDP) in Cambodia?
Offer a very short reply. 33.8. In the year 2011, what is the difference between the Claims (% of GDP) of Sub-Saharan Africa (developing only) and Claims (% of GDP) of Denmark?
Provide a short and direct response. -186.89. In the year 2011, what is the difference between the Claims (% of GDP) of Sub-Saharan Africa (developing only) and Claims (% of GDP) of Poland?
Keep it short and to the point. 4.12. In the year 2011, what is the difference between the Claims (% of GDP) of Cambodia and Claims (% of GDP) of Denmark?
Offer a terse response. -220.69. In the year 2011, what is the difference between the Claims (% of GDP) of Cambodia and Claims (% of GDP) of Poland?
Offer a very short reply. -29.68. In the year 2011, what is the difference between the Claims (% of GDP) in Denmark and Claims (% of GDP) in Poland?
Keep it short and to the point. 191.01. What is the ratio of the Claims (% of GDP) of Sub-Saharan Africa (developing only) in 2005 to that in 2006?
Provide a short and direct response. 0.98. What is the ratio of the Claims (% of GDP) of Cambodia in 2005 to that in 2006?
Your answer should be very brief. 0.75. What is the ratio of the Claims (% of GDP) of Denmark in 2005 to that in 2006?
Your answer should be compact. 0.94. What is the ratio of the Claims (% of GDP) in Poland in 2005 to that in 2006?
Keep it short and to the point. 0.89. What is the ratio of the Claims (% of GDP) in Sub-Saharan Africa (developing only) in 2005 to that in 2007?
Your response must be concise. 0.96. What is the ratio of the Claims (% of GDP) in Cambodia in 2005 to that in 2007?
Offer a very short reply. 0.5. What is the ratio of the Claims (% of GDP) of Denmark in 2005 to that in 2007?
Ensure brevity in your answer.  0.84. What is the ratio of the Claims (% of GDP) of Poland in 2005 to that in 2007?
Make the answer very short. 0.75. What is the ratio of the Claims (% of GDP) of Sub-Saharan Africa (developing only) in 2005 to that in 2008?
Keep it short and to the point. 1.14. What is the ratio of the Claims (% of GDP) in Cambodia in 2005 to that in 2008?
Ensure brevity in your answer.  0.39. What is the ratio of the Claims (% of GDP) of Denmark in 2005 to that in 2008?
Give a very brief answer. 0.73. What is the ratio of the Claims (% of GDP) of Poland in 2005 to that in 2008?
Your answer should be compact. 0.58. What is the ratio of the Claims (% of GDP) of Sub-Saharan Africa (developing only) in 2005 to that in 2009?
Offer a terse response. 1.01. What is the ratio of the Claims (% of GDP) of Cambodia in 2005 to that in 2009?
Your answer should be compact. 0.37. What is the ratio of the Claims (% of GDP) in Denmark in 2005 to that in 2009?
Your response must be concise. 0.75. What is the ratio of the Claims (% of GDP) in Poland in 2005 to that in 2009?
Your answer should be very brief. 0.6. What is the ratio of the Claims (% of GDP) of Sub-Saharan Africa (developing only) in 2005 to that in 2010?
Offer a very short reply. 1.15. What is the ratio of the Claims (% of GDP) in Cambodia in 2005 to that in 2010?
Give a very brief answer. 0.33. What is the ratio of the Claims (% of GDP) in Denmark in 2005 to that in 2010?
Your response must be concise. 0.76. What is the ratio of the Claims (% of GDP) of Poland in 2005 to that in 2010?
Offer a terse response. 0.59. What is the ratio of the Claims (% of GDP) in Sub-Saharan Africa (developing only) in 2005 to that in 2011?
Provide a succinct answer. 1.2. What is the ratio of the Claims (% of GDP) in Cambodia in 2005 to that in 2011?
Keep it short and to the point. 0.32. What is the ratio of the Claims (% of GDP) of Denmark in 2005 to that in 2011?
Ensure brevity in your answer.  0.74. What is the ratio of the Claims (% of GDP) of Poland in 2005 to that in 2011?
Your answer should be compact. 0.55. What is the ratio of the Claims (% of GDP) of Sub-Saharan Africa (developing only) in 2006 to that in 2007?
Your answer should be very brief. 0.97. What is the ratio of the Claims (% of GDP) in Cambodia in 2006 to that in 2007?
Make the answer very short. 0.66. What is the ratio of the Claims (% of GDP) of Denmark in 2006 to that in 2007?
Your answer should be very brief. 0.9. What is the ratio of the Claims (% of GDP) of Poland in 2006 to that in 2007?
Offer a very short reply. 0.85. What is the ratio of the Claims (% of GDP) of Sub-Saharan Africa (developing only) in 2006 to that in 2008?
Keep it short and to the point. 1.16. What is the ratio of the Claims (% of GDP) in Cambodia in 2006 to that in 2008?
Your answer should be compact. 0.51. What is the ratio of the Claims (% of GDP) in Denmark in 2006 to that in 2008?
Provide a short and direct response. 0.78. What is the ratio of the Claims (% of GDP) of Poland in 2006 to that in 2008?
Ensure brevity in your answer.  0.66. What is the ratio of the Claims (% of GDP) in Sub-Saharan Africa (developing only) in 2006 to that in 2009?
Make the answer very short. 1.03. What is the ratio of the Claims (% of GDP) in Cambodia in 2006 to that in 2009?
Provide a succinct answer. 0.49. What is the ratio of the Claims (% of GDP) in Denmark in 2006 to that in 2009?
Ensure brevity in your answer.  0.8. What is the ratio of the Claims (% of GDP) in Poland in 2006 to that in 2009?
Provide a short and direct response. 0.68. What is the ratio of the Claims (% of GDP) in Sub-Saharan Africa (developing only) in 2006 to that in 2010?
Make the answer very short. 1.17. What is the ratio of the Claims (% of GDP) of Cambodia in 2006 to that in 2010?
Ensure brevity in your answer.  0.44. What is the ratio of the Claims (% of GDP) of Denmark in 2006 to that in 2010?
Keep it short and to the point. 0.81. What is the ratio of the Claims (% of GDP) of Poland in 2006 to that in 2010?
Your answer should be very brief. 0.66. What is the ratio of the Claims (% of GDP) of Sub-Saharan Africa (developing only) in 2006 to that in 2011?
Offer a very short reply. 1.22. What is the ratio of the Claims (% of GDP) in Cambodia in 2006 to that in 2011?
Offer a very short reply. 0.42. What is the ratio of the Claims (% of GDP) of Denmark in 2006 to that in 2011?
Keep it short and to the point. 0.79. What is the ratio of the Claims (% of GDP) of Poland in 2006 to that in 2011?
Keep it short and to the point. 0.62. What is the ratio of the Claims (% of GDP) of Sub-Saharan Africa (developing only) in 2007 to that in 2008?
Your answer should be compact. 1.2. What is the ratio of the Claims (% of GDP) of Cambodia in 2007 to that in 2008?
Give a very brief answer. 0.78. What is the ratio of the Claims (% of GDP) in Denmark in 2007 to that in 2008?
Your answer should be very brief. 0.86. What is the ratio of the Claims (% of GDP) of Poland in 2007 to that in 2008?
Your answer should be compact. 0.77. What is the ratio of the Claims (% of GDP) of Sub-Saharan Africa (developing only) in 2007 to that in 2009?
Your response must be concise. 1.06. What is the ratio of the Claims (% of GDP) in Cambodia in 2007 to that in 2009?
Ensure brevity in your answer.  0.74. What is the ratio of the Claims (% of GDP) of Denmark in 2007 to that in 2009?
Provide a succinct answer. 0.88. What is the ratio of the Claims (% of GDP) of Poland in 2007 to that in 2009?
Your answer should be very brief. 0.8. What is the ratio of the Claims (% of GDP) in Sub-Saharan Africa (developing only) in 2007 to that in 2010?
Provide a short and direct response. 1.2. What is the ratio of the Claims (% of GDP) of Cambodia in 2007 to that in 2010?
Keep it short and to the point. 0.66. What is the ratio of the Claims (% of GDP) of Denmark in 2007 to that in 2010?
Your response must be concise. 0.89. What is the ratio of the Claims (% of GDP) of Poland in 2007 to that in 2010?
Provide a succinct answer. 0.78. What is the ratio of the Claims (% of GDP) of Sub-Saharan Africa (developing only) in 2007 to that in 2011?
Keep it short and to the point. 1.26. What is the ratio of the Claims (% of GDP) in Cambodia in 2007 to that in 2011?
Your answer should be compact. 0.64. What is the ratio of the Claims (% of GDP) in Denmark in 2007 to that in 2011?
Offer a terse response. 0.88. What is the ratio of the Claims (% of GDP) in Poland in 2007 to that in 2011?
Offer a terse response. 0.73. What is the ratio of the Claims (% of GDP) of Sub-Saharan Africa (developing only) in 2008 to that in 2009?
Your answer should be compact. 0.88. What is the ratio of the Claims (% of GDP) in Cambodia in 2008 to that in 2009?
Your response must be concise. 0.95. What is the ratio of the Claims (% of GDP) in Denmark in 2008 to that in 2009?
Make the answer very short. 1.02. What is the ratio of the Claims (% of GDP) of Poland in 2008 to that in 2009?
Your answer should be very brief. 1.03. What is the ratio of the Claims (% of GDP) of Sub-Saharan Africa (developing only) in 2008 to that in 2010?
Offer a very short reply. 1.01. What is the ratio of the Claims (% of GDP) in Cambodia in 2008 to that in 2010?
Give a very brief answer. 0.85. What is the ratio of the Claims (% of GDP) in Denmark in 2008 to that in 2010?
Your answer should be very brief. 1.04. What is the ratio of the Claims (% of GDP) in Poland in 2008 to that in 2010?
Ensure brevity in your answer.  1.01. What is the ratio of the Claims (% of GDP) in Sub-Saharan Africa (developing only) in 2008 to that in 2011?
Offer a terse response. 1.05. What is the ratio of the Claims (% of GDP) in Cambodia in 2008 to that in 2011?
Make the answer very short. 0.83. What is the ratio of the Claims (% of GDP) in Denmark in 2008 to that in 2011?
Offer a terse response. 1.01. What is the ratio of the Claims (% of GDP) in Poland in 2008 to that in 2011?
Provide a short and direct response. 0.95. What is the ratio of the Claims (% of GDP) in Sub-Saharan Africa (developing only) in 2009 to that in 2010?
Give a very brief answer. 1.14. What is the ratio of the Claims (% of GDP) in Cambodia in 2009 to that in 2010?
Your answer should be compact. 0.89. What is the ratio of the Claims (% of GDP) of Denmark in 2009 to that in 2010?
Offer a very short reply. 1.01. What is the ratio of the Claims (% of GDP) of Poland in 2009 to that in 2010?
Keep it short and to the point. 0.98. What is the ratio of the Claims (% of GDP) in Sub-Saharan Africa (developing only) in 2009 to that in 2011?
Offer a very short reply. 1.19. What is the ratio of the Claims (% of GDP) of Cambodia in 2009 to that in 2011?
Ensure brevity in your answer.  0.87. What is the ratio of the Claims (% of GDP) of Denmark in 2009 to that in 2011?
Your answer should be compact. 0.99. What is the ratio of the Claims (% of GDP) of Poland in 2009 to that in 2011?
Your answer should be compact. 0.92. What is the ratio of the Claims (% of GDP) in Sub-Saharan Africa (developing only) in 2010 to that in 2011?
Give a very brief answer. 1.05. What is the ratio of the Claims (% of GDP) in Cambodia in 2010 to that in 2011?
Ensure brevity in your answer.  0.97. What is the ratio of the Claims (% of GDP) in Denmark in 2010 to that in 2011?
Ensure brevity in your answer.  0.98. What is the ratio of the Claims (% of GDP) of Poland in 2010 to that in 2011?
Your response must be concise. 0.94. What is the difference between the highest and the second highest Claims (% of GDP) in Sub-Saharan Africa (developing only)?
Give a very brief answer. 2.25. What is the difference between the highest and the second highest Claims (% of GDP) in Cambodia?
Provide a succinct answer. 0.83. What is the difference between the highest and the second highest Claims (% of GDP) of Denmark?
Offer a terse response. 3.62. What is the difference between the highest and the second highest Claims (% of GDP) in Poland?
Provide a short and direct response. 2.9. What is the difference between the highest and the lowest Claims (% of GDP) in Sub-Saharan Africa (developing only)?
Keep it short and to the point. 16.2. What is the difference between the highest and the lowest Claims (% of GDP) in Cambodia?
Provide a succinct answer. 19.42. What is the difference between the highest and the lowest Claims (% of GDP) in Denmark?
Provide a short and direct response. 68.58. What is the difference between the highest and the lowest Claims (% of GDP) in Poland?
Make the answer very short. 26.09. 